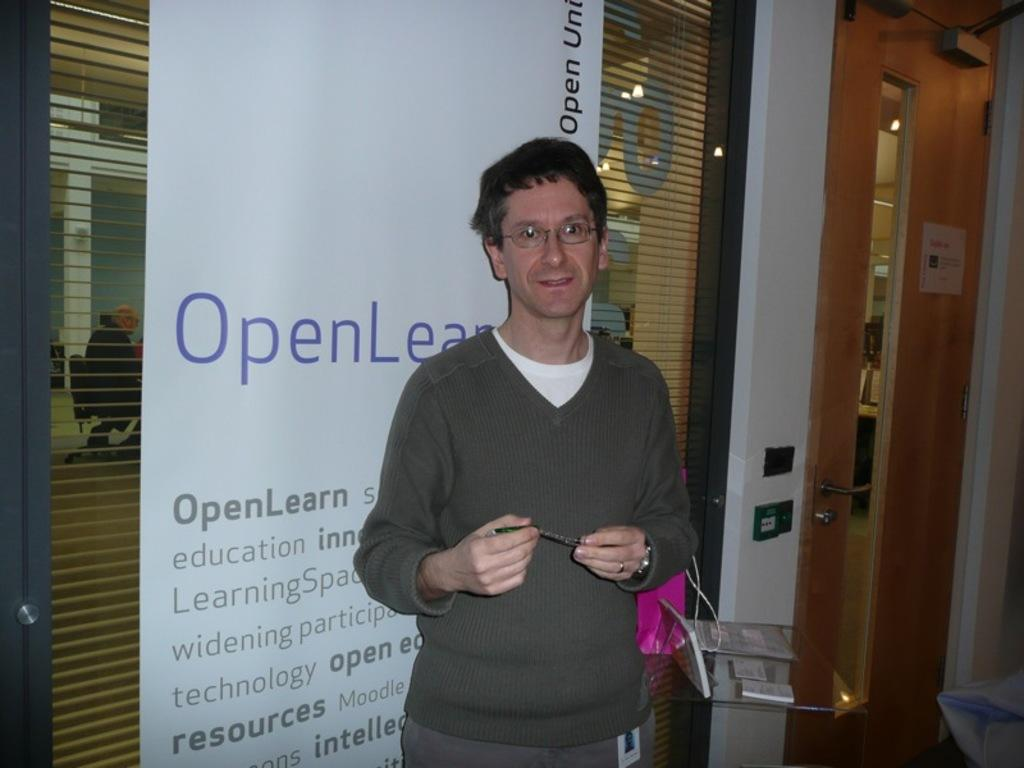What is the main subject in the middle of the image? There is a person standing in the middle of the image. What can be seen on the right side of the image? There is a door on the right side of the image. What is behind the person in the image? There is a banner behind the person. What type of clothing is the person wearing? The person is wearing a sweater. What type of eyewear is the person wearing? The person is wearing goggles. What type of pest can be seen crawling on the person's sweater in the image? There are no pests visible on the person's sweater in the image. How many drawers are present in the image? There is no mention of drawers in the provided facts, so it cannot be determined from the image. 